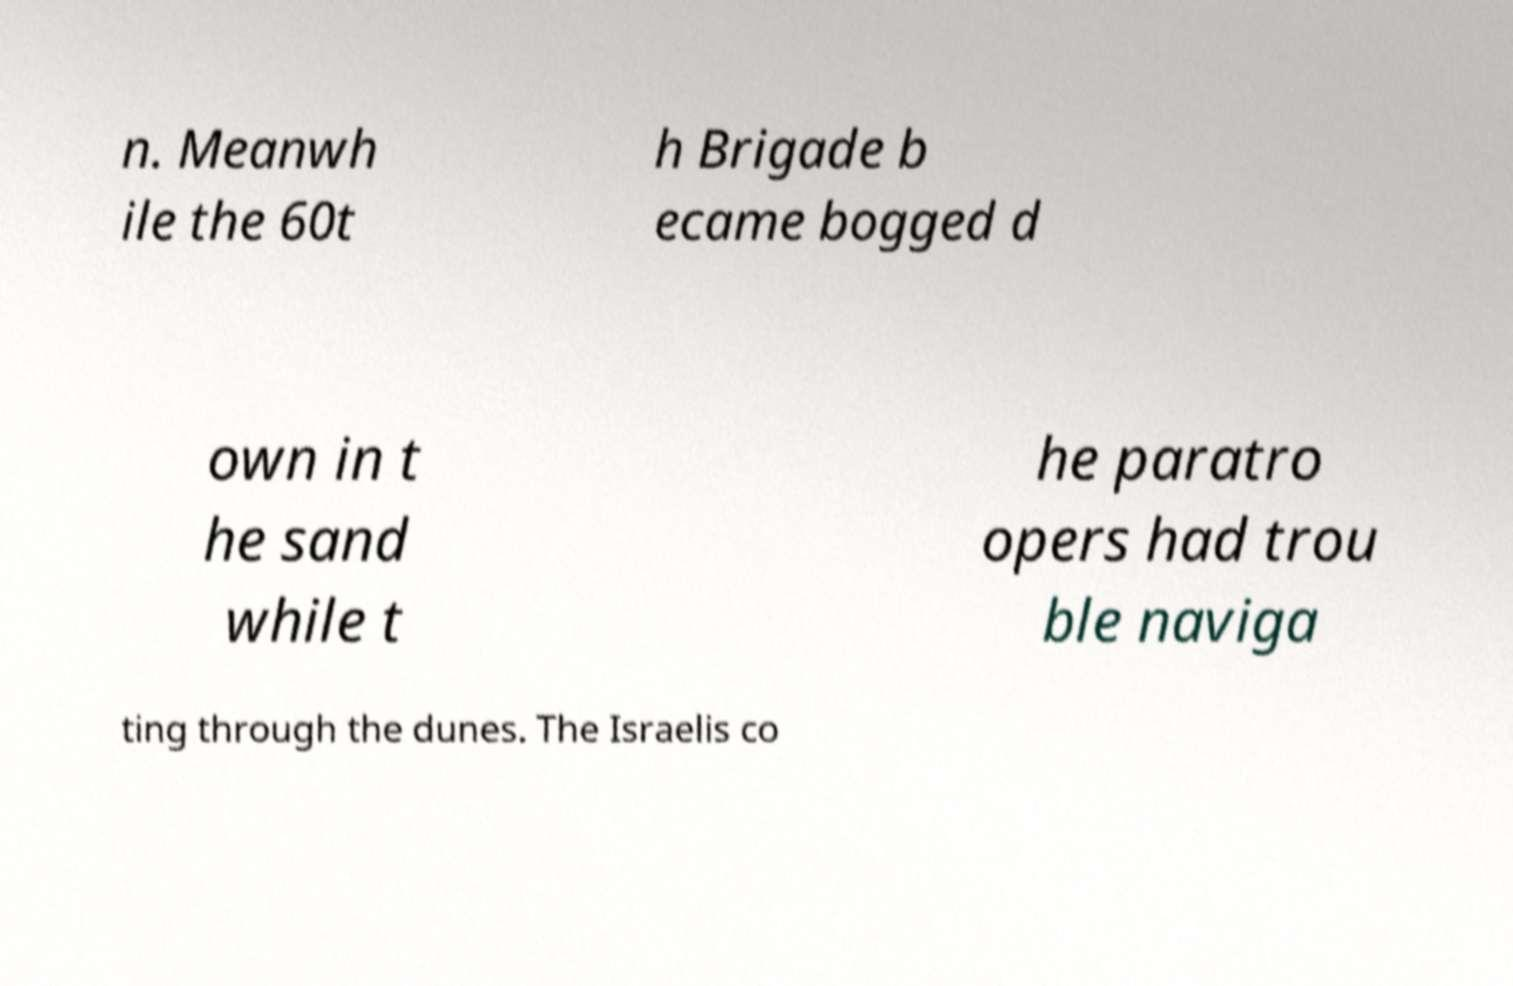There's text embedded in this image that I need extracted. Can you transcribe it verbatim? n. Meanwh ile the 60t h Brigade b ecame bogged d own in t he sand while t he paratro opers had trou ble naviga ting through the dunes. The Israelis co 